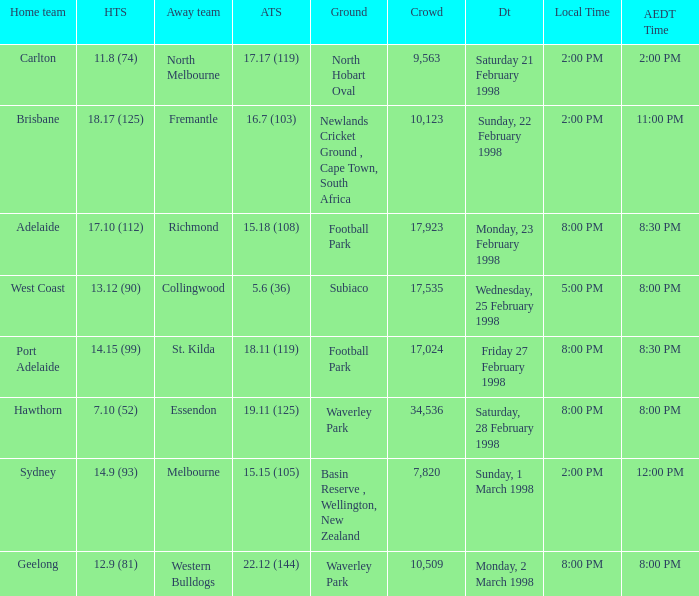Which Home team score has a AEDT Time of 11:00 pm? 18.17 (125). Can you give me this table as a dict? {'header': ['Home team', 'HTS', 'Away team', 'ATS', 'Ground', 'Crowd', 'Dt', 'Local Time', 'AEDT Time'], 'rows': [['Carlton', '11.8 (74)', 'North Melbourne', '17.17 (119)', 'North Hobart Oval', '9,563', 'Saturday 21 February 1998', '2:00 PM', '2:00 PM'], ['Brisbane', '18.17 (125)', 'Fremantle', '16.7 (103)', 'Newlands Cricket Ground , Cape Town, South Africa', '10,123', 'Sunday, 22 February 1998', '2:00 PM', '11:00 PM'], ['Adelaide', '17.10 (112)', 'Richmond', '15.18 (108)', 'Football Park', '17,923', 'Monday, 23 February 1998', '8:00 PM', '8:30 PM'], ['West Coast', '13.12 (90)', 'Collingwood', '5.6 (36)', 'Subiaco', '17,535', 'Wednesday, 25 February 1998', '5:00 PM', '8:00 PM'], ['Port Adelaide', '14.15 (99)', 'St. Kilda', '18.11 (119)', 'Football Park', '17,024', 'Friday 27 February 1998', '8:00 PM', '8:30 PM'], ['Hawthorn', '7.10 (52)', 'Essendon', '19.11 (125)', 'Waverley Park', '34,536', 'Saturday, 28 February 1998', '8:00 PM', '8:00 PM'], ['Sydney', '14.9 (93)', 'Melbourne', '15.15 (105)', 'Basin Reserve , Wellington, New Zealand', '7,820', 'Sunday, 1 March 1998', '2:00 PM', '12:00 PM'], ['Geelong', '12.9 (81)', 'Western Bulldogs', '22.12 (144)', 'Waverley Park', '10,509', 'Monday, 2 March 1998', '8:00 PM', '8:00 PM']]} 